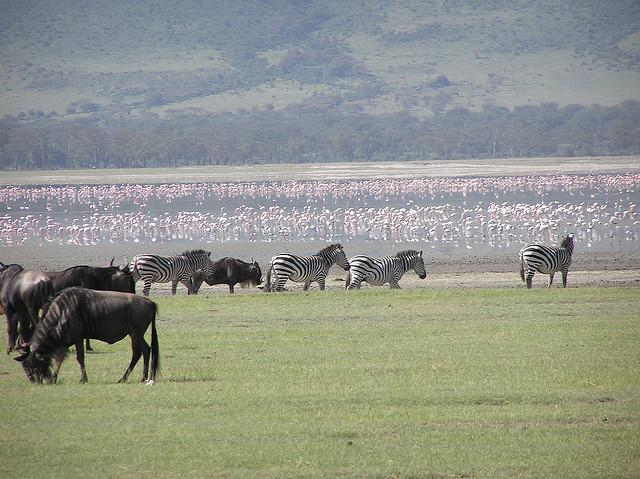Which animal is the weakest?

Choices:
A) flamingo
B) wildebeest
C) zebra
D) none flamingo 